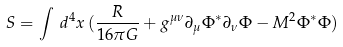<formula> <loc_0><loc_0><loc_500><loc_500>S = \int \, d ^ { 4 } x \, ( { \frac { R } { 1 6 \pi G } + g ^ { \mu \nu } \partial _ { \mu } \Phi ^ { \ast } \partial _ { \nu } \Phi - M ^ { 2 } \Phi ^ { \ast } \Phi } )</formula> 